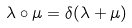Convert formula to latex. <formula><loc_0><loc_0><loc_500><loc_500>\lambda \circ \mu = \delta ( \lambda + \mu )</formula> 